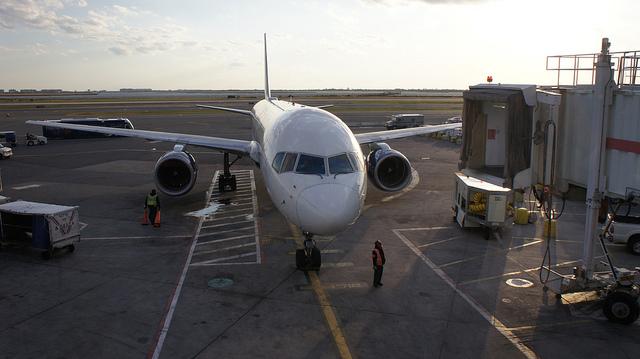How many men are carrying traffic cones?
Give a very brief answer. 1. Are they loading the plane?
Answer briefly. No. Is this plane taking off?
Give a very brief answer. No. 